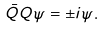<formula> <loc_0><loc_0><loc_500><loc_500>\bar { Q } Q \psi = \pm i \psi .</formula> 